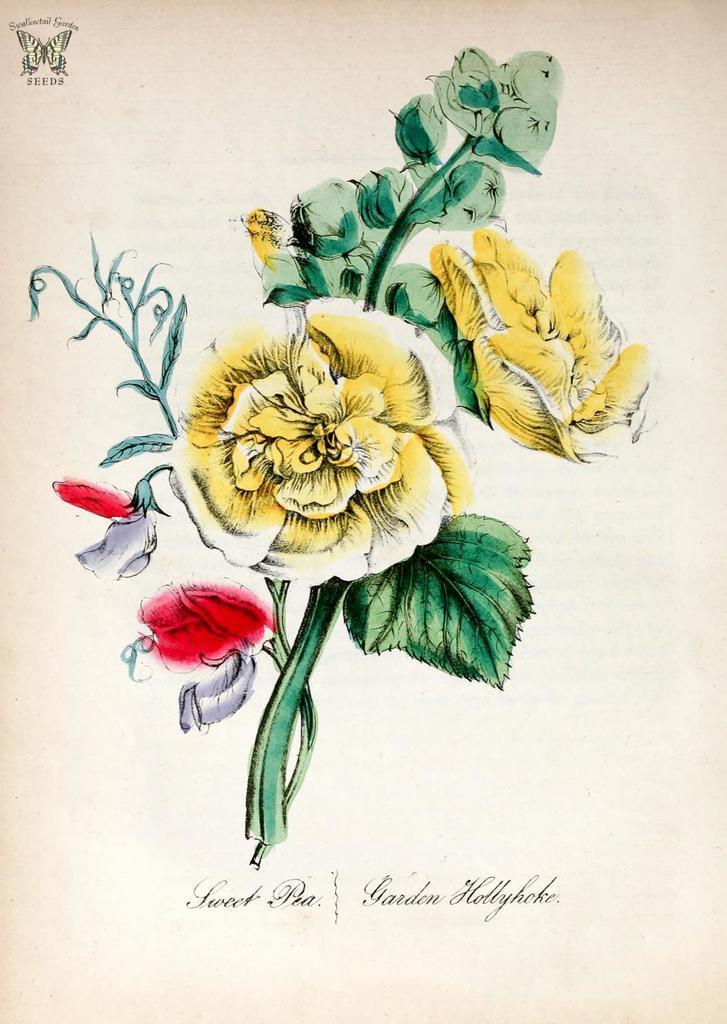Could you give a brief overview of what you see in this image? This image consists of a poster. In the middle there are flowers, leaves, stems. At the bottom there is a text. At the top there is a logo and text. 